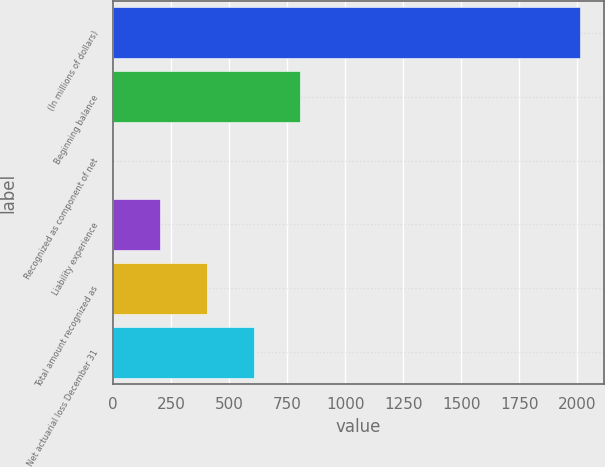Convert chart. <chart><loc_0><loc_0><loc_500><loc_500><bar_chart><fcel>(In millions of dollars)<fcel>Beginning balance<fcel>Recognized as component of net<fcel>Liability experience<fcel>Total amount recognized as<fcel>Net actuarial loss December 31<nl><fcel>2014<fcel>806.2<fcel>1<fcel>202.3<fcel>403.6<fcel>604.9<nl></chart> 